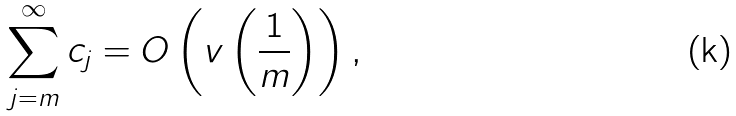Convert formula to latex. <formula><loc_0><loc_0><loc_500><loc_500>\sum _ { j = m } ^ { \infty } c _ { j } = O \left ( v \left ( \frac { 1 } { m } \right ) \right ) ,</formula> 